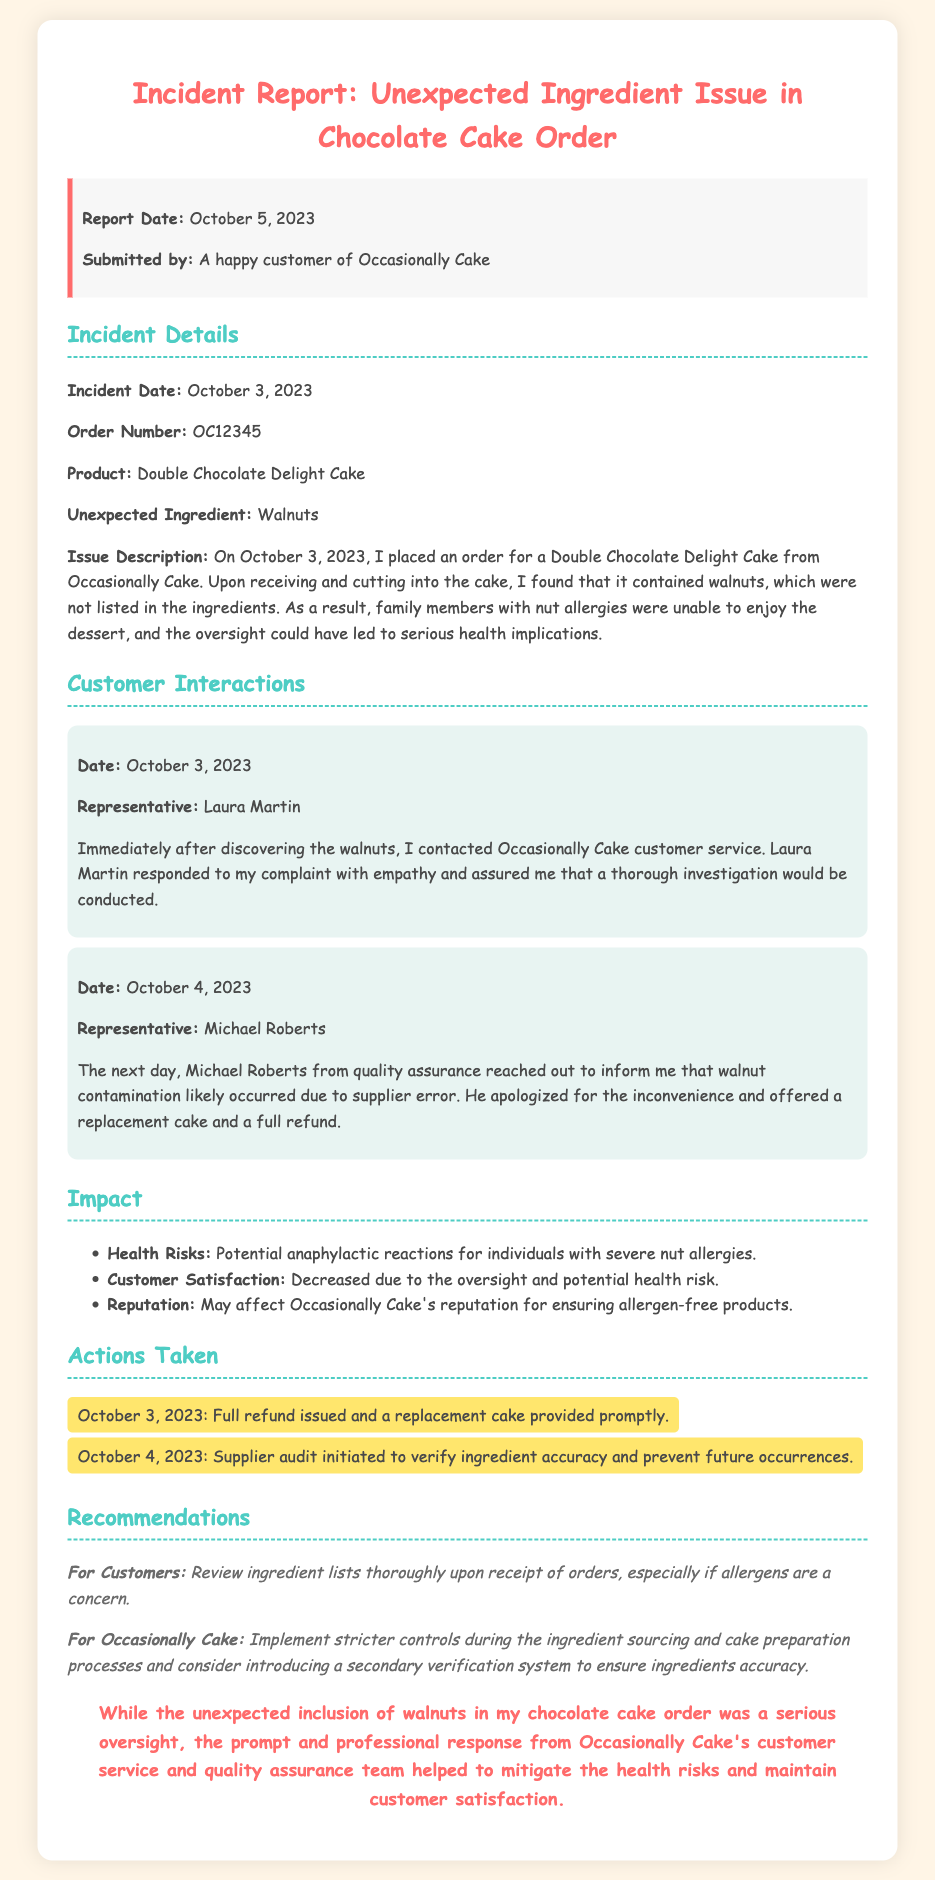What is the report date? The report date is mentioned in the info box of the document.
Answer: October 5, 2023 What was the unexpected ingredient found in the cake? The unexpected ingredient is detailed in the incident details section.
Answer: Walnuts Who was the customer service representative first contacted? The first representative mentioned in the customer interactions section is listed before others.
Answer: Laura Martin When did the incident occur? The incident date is specified in the incident details section.
Answer: October 3, 2023 What action was taken on October 4, 2023? Actions taken are listed, including the specific day and the action taken.
Answer: Supplier audit initiated What was offered to the customer as a resolution? The resolution offered is described in the customer interactions section by a representative.
Answer: Replacement cake and a full refund What is one of the health risks mentioned in the report? The health risks are detailed in the impact section of the document.
Answer: Potential anaphylactic reactions What is a recommendation for Occasionally Cake? Recommendations for the company are outlined in the recommendations section.
Answer: Implement stricter controls What is the order number mentioned in the report? The order number is provided in the incident details for identifying the specific order.
Answer: OC12345 